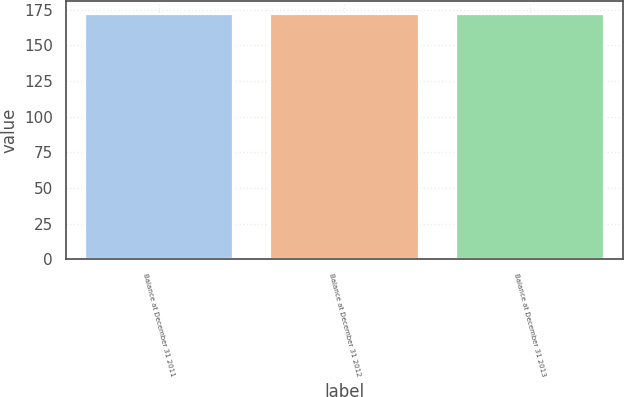Convert chart. <chart><loc_0><loc_0><loc_500><loc_500><bar_chart><fcel>Balance at December 31 2011<fcel>Balance at December 31 2012<fcel>Balance at December 31 2013<nl><fcel>172<fcel>172.1<fcel>172.2<nl></chart> 